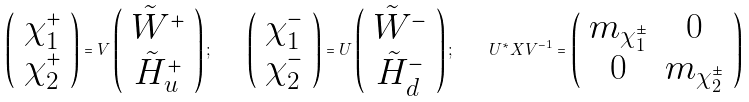Convert formula to latex. <formula><loc_0><loc_0><loc_500><loc_500>\left ( \begin{array} { c } \chi _ { 1 } ^ { + } \\ \chi _ { 2 } ^ { + } \end{array} \right ) = { V } \left ( \begin{array} { c } \tilde { W } ^ { + } \\ \tilde { H } _ { u } ^ { + } \end{array} \right ) ; \quad \left ( \begin{array} { c } \chi _ { 1 } ^ { - } \\ \chi _ { 2 } ^ { - } \end{array} \right ) = { U } \left ( \begin{array} { c } \tilde { W } ^ { - } \\ \tilde { H } _ { d } ^ { - } \end{array} \right ) ; \quad { U ^ { * } X V ^ { - 1 } } = \left ( \begin{array} { c c } m _ { \chi _ { 1 } ^ { \pm } } & 0 \\ 0 & m _ { \chi _ { 2 } ^ { \pm } } \end{array} \right )</formula> 